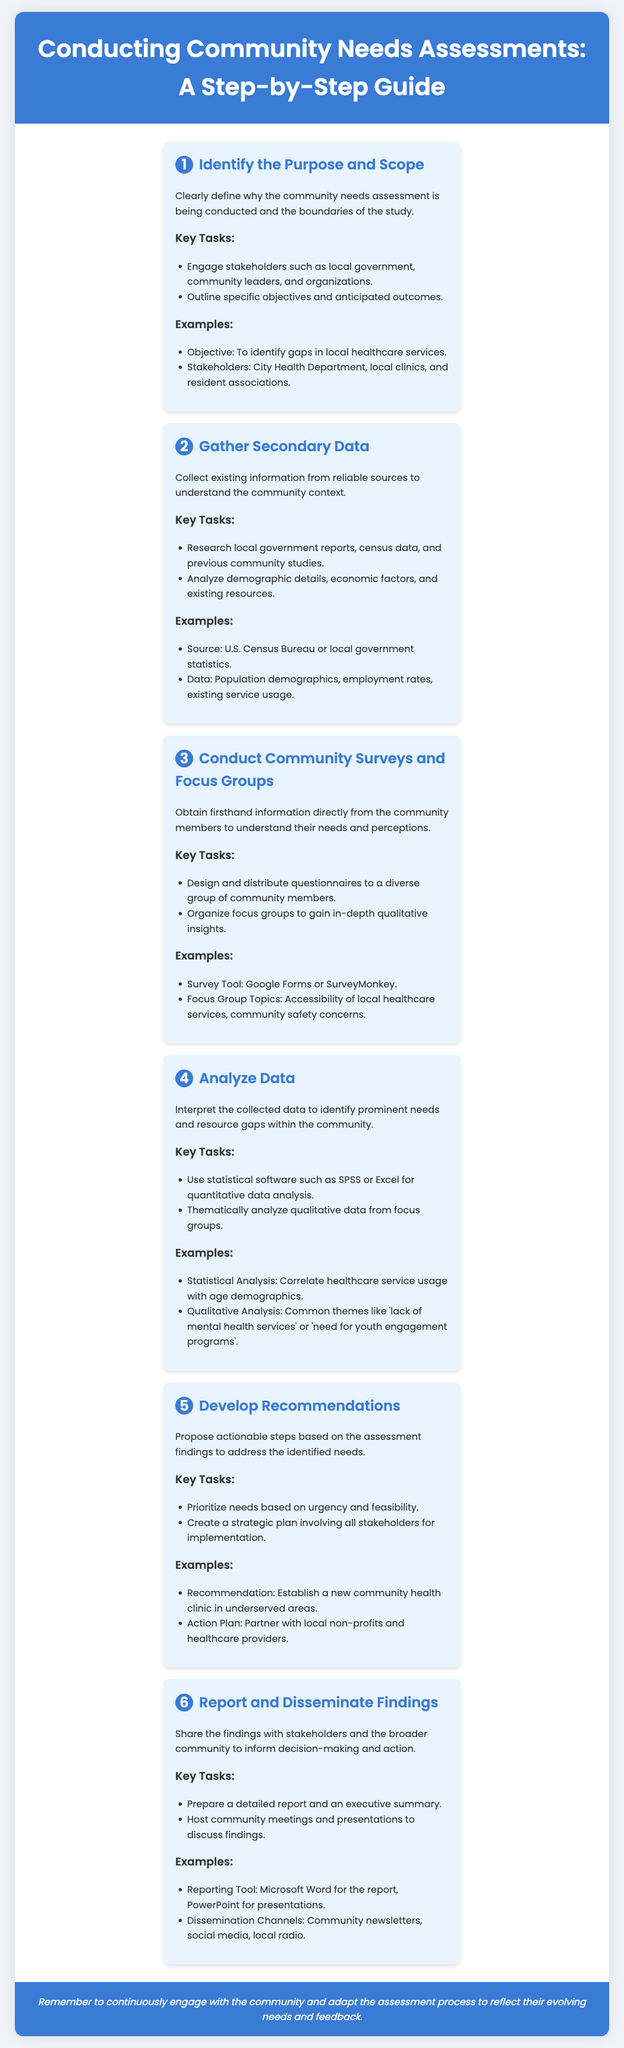What is the first step in conducting a community needs assessment? The first step is to identify the purpose and scope of the assessment.
Answer: Identify the Purpose and Scope Which software can be used for quantitative data analysis? The document mentions using statistical software such as SPSS or Excel for quantitative data analysis.
Answer: SPSS or Excel How many steps are outlined in the community needs assessment guide? The document outlines a total of six steps in the community needs assessment guide.
Answer: Six steps What is an example of a recommendation from the assessment? One of the examples of a recommendation is to establish a new community health clinic in underserved areas.
Answer: Establish a new community health clinic What key task is mentioned for developing recommendations? One key task is to prioritize needs based on urgency and feasibility.
Answer: Prioritize needs based on urgency and feasibility What type of data is analyzed qualitatively? Qualitative data collected from focus groups is thematically analyzed.
Answer: Thematically analyze qualitative data Which stakeholders should be engaged first during the needs assessment? Local government, community leaders, and organizations are the stakeholders that should be engaged first.
Answer: Local government, community leaders, and organizations What reporting tool is suggested for preparing a detailed report? The document suggests using Microsoft Word as a reporting tool for preparing a detailed report.
Answer: Microsoft Word 